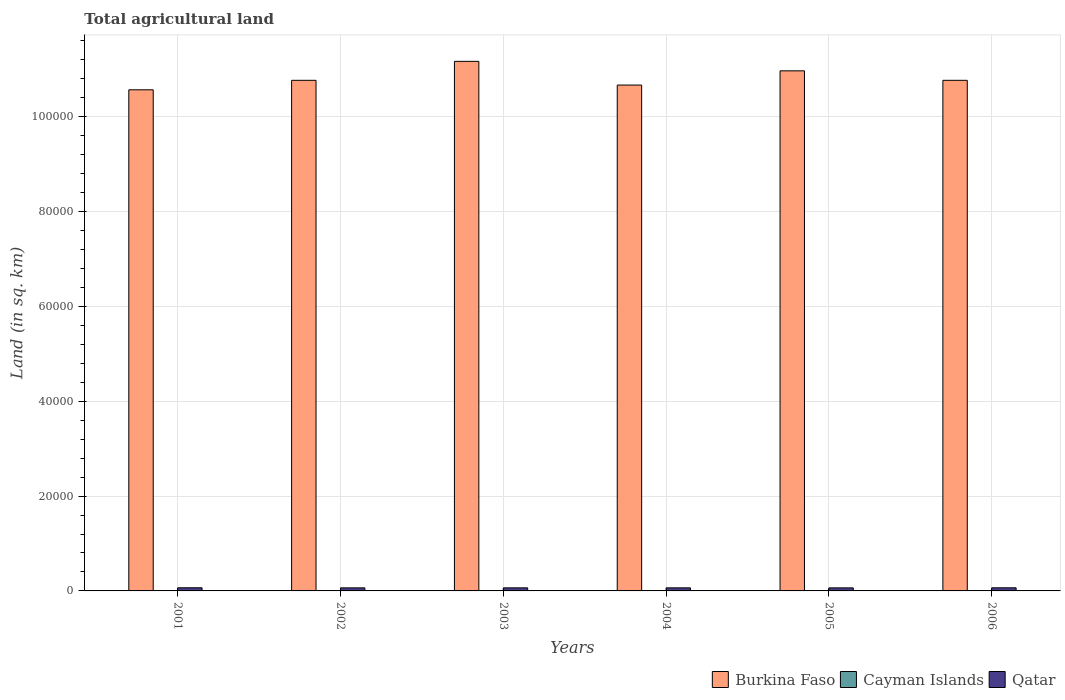How many different coloured bars are there?
Offer a terse response. 3. How many groups of bars are there?
Your answer should be compact. 6. Are the number of bars per tick equal to the number of legend labels?
Your answer should be very brief. Yes. Are the number of bars on each tick of the X-axis equal?
Your answer should be very brief. Yes. How many bars are there on the 1st tick from the left?
Offer a very short reply. 3. How many bars are there on the 2nd tick from the right?
Your response must be concise. 3. What is the label of the 6th group of bars from the left?
Give a very brief answer. 2006. In how many cases, is the number of bars for a given year not equal to the number of legend labels?
Ensure brevity in your answer.  0. What is the total agricultural land in Cayman Islands in 2003?
Keep it short and to the point. 27. Across all years, what is the maximum total agricultural land in Cayman Islands?
Keep it short and to the point. 27. Across all years, what is the minimum total agricultural land in Burkina Faso?
Your response must be concise. 1.06e+05. In which year was the total agricultural land in Burkina Faso minimum?
Ensure brevity in your answer.  2001. What is the total total agricultural land in Burkina Faso in the graph?
Ensure brevity in your answer.  6.49e+05. What is the difference between the total agricultural land in Qatar in 2005 and the total agricultural land in Cayman Islands in 2002?
Provide a short and direct response. 615. What is the average total agricultural land in Qatar per year?
Ensure brevity in your answer.  649.67. In the year 2001, what is the difference between the total agricultural land in Cayman Islands and total agricultural land in Qatar?
Offer a terse response. -636. In how many years, is the total agricultural land in Qatar greater than 20000 sq.km?
Your answer should be compact. 0. Is the total agricultural land in Burkina Faso in 2003 less than that in 2004?
Provide a succinct answer. No. What is the difference between the highest and the second highest total agricultural land in Burkina Faso?
Offer a very short reply. 2000. What is the difference between the highest and the lowest total agricultural land in Cayman Islands?
Offer a terse response. 0. In how many years, is the total agricultural land in Qatar greater than the average total agricultural land in Qatar taken over all years?
Make the answer very short. 2. What does the 2nd bar from the left in 2001 represents?
Keep it short and to the point. Cayman Islands. What does the 1st bar from the right in 2003 represents?
Your response must be concise. Qatar. How many years are there in the graph?
Keep it short and to the point. 6. What is the difference between two consecutive major ticks on the Y-axis?
Your response must be concise. 2.00e+04. What is the title of the graph?
Ensure brevity in your answer.  Total agricultural land. Does "Sub-Saharan Africa (all income levels)" appear as one of the legend labels in the graph?
Offer a very short reply. No. What is the label or title of the Y-axis?
Your answer should be very brief. Land (in sq. km). What is the Land (in sq. km) in Burkina Faso in 2001?
Keep it short and to the point. 1.06e+05. What is the Land (in sq. km) of Cayman Islands in 2001?
Ensure brevity in your answer.  27. What is the Land (in sq. km) of Qatar in 2001?
Your answer should be compact. 663. What is the Land (in sq. km) of Burkina Faso in 2002?
Offer a terse response. 1.08e+05. What is the Land (in sq. km) in Cayman Islands in 2002?
Ensure brevity in your answer.  27. What is the Land (in sq. km) in Qatar in 2002?
Offer a very short reply. 645. What is the Land (in sq. km) in Burkina Faso in 2003?
Give a very brief answer. 1.12e+05. What is the Land (in sq. km) in Qatar in 2003?
Offer a terse response. 646. What is the Land (in sq. km) in Burkina Faso in 2004?
Keep it short and to the point. 1.07e+05. What is the Land (in sq. km) of Qatar in 2004?
Offer a terse response. 646. What is the Land (in sq. km) of Burkina Faso in 2005?
Your answer should be compact. 1.10e+05. What is the Land (in sq. km) in Cayman Islands in 2005?
Your answer should be very brief. 27. What is the Land (in sq. km) in Qatar in 2005?
Your answer should be compact. 642. What is the Land (in sq. km) in Burkina Faso in 2006?
Make the answer very short. 1.08e+05. What is the Land (in sq. km) in Cayman Islands in 2006?
Offer a terse response. 27. What is the Land (in sq. km) of Qatar in 2006?
Offer a terse response. 656. Across all years, what is the maximum Land (in sq. km) of Burkina Faso?
Your response must be concise. 1.12e+05. Across all years, what is the maximum Land (in sq. km) in Qatar?
Your answer should be compact. 663. Across all years, what is the minimum Land (in sq. km) in Burkina Faso?
Provide a succinct answer. 1.06e+05. Across all years, what is the minimum Land (in sq. km) in Cayman Islands?
Offer a terse response. 27. Across all years, what is the minimum Land (in sq. km) in Qatar?
Your answer should be very brief. 642. What is the total Land (in sq. km) of Burkina Faso in the graph?
Ensure brevity in your answer.  6.49e+05. What is the total Land (in sq. km) in Cayman Islands in the graph?
Provide a succinct answer. 162. What is the total Land (in sq. km) of Qatar in the graph?
Provide a succinct answer. 3898. What is the difference between the Land (in sq. km) in Burkina Faso in 2001 and that in 2002?
Your answer should be compact. -2000. What is the difference between the Land (in sq. km) in Qatar in 2001 and that in 2002?
Give a very brief answer. 18. What is the difference between the Land (in sq. km) in Burkina Faso in 2001 and that in 2003?
Make the answer very short. -6000. What is the difference between the Land (in sq. km) in Burkina Faso in 2001 and that in 2004?
Your answer should be compact. -1000. What is the difference between the Land (in sq. km) of Cayman Islands in 2001 and that in 2004?
Your answer should be very brief. 0. What is the difference between the Land (in sq. km) of Qatar in 2001 and that in 2004?
Ensure brevity in your answer.  17. What is the difference between the Land (in sq. km) of Burkina Faso in 2001 and that in 2005?
Your response must be concise. -4000. What is the difference between the Land (in sq. km) of Qatar in 2001 and that in 2005?
Keep it short and to the point. 21. What is the difference between the Land (in sq. km) of Burkina Faso in 2001 and that in 2006?
Keep it short and to the point. -2000. What is the difference between the Land (in sq. km) in Cayman Islands in 2001 and that in 2006?
Keep it short and to the point. 0. What is the difference between the Land (in sq. km) of Burkina Faso in 2002 and that in 2003?
Ensure brevity in your answer.  -4000. What is the difference between the Land (in sq. km) of Qatar in 2002 and that in 2004?
Offer a terse response. -1. What is the difference between the Land (in sq. km) in Burkina Faso in 2002 and that in 2005?
Give a very brief answer. -2000. What is the difference between the Land (in sq. km) of Cayman Islands in 2002 and that in 2005?
Provide a short and direct response. 0. What is the difference between the Land (in sq. km) in Qatar in 2002 and that in 2005?
Give a very brief answer. 3. What is the difference between the Land (in sq. km) of Cayman Islands in 2002 and that in 2006?
Keep it short and to the point. 0. What is the difference between the Land (in sq. km) of Cayman Islands in 2003 and that in 2004?
Keep it short and to the point. 0. What is the difference between the Land (in sq. km) of Qatar in 2003 and that in 2005?
Offer a very short reply. 4. What is the difference between the Land (in sq. km) in Burkina Faso in 2003 and that in 2006?
Offer a very short reply. 4000. What is the difference between the Land (in sq. km) in Cayman Islands in 2003 and that in 2006?
Offer a terse response. 0. What is the difference between the Land (in sq. km) of Burkina Faso in 2004 and that in 2005?
Provide a succinct answer. -3000. What is the difference between the Land (in sq. km) of Qatar in 2004 and that in 2005?
Your answer should be very brief. 4. What is the difference between the Land (in sq. km) of Burkina Faso in 2004 and that in 2006?
Your answer should be compact. -1000. What is the difference between the Land (in sq. km) in Qatar in 2004 and that in 2006?
Your response must be concise. -10. What is the difference between the Land (in sq. km) of Burkina Faso in 2005 and that in 2006?
Offer a terse response. 2000. What is the difference between the Land (in sq. km) of Burkina Faso in 2001 and the Land (in sq. km) of Cayman Islands in 2002?
Provide a short and direct response. 1.06e+05. What is the difference between the Land (in sq. km) of Burkina Faso in 2001 and the Land (in sq. km) of Qatar in 2002?
Ensure brevity in your answer.  1.05e+05. What is the difference between the Land (in sq. km) in Cayman Islands in 2001 and the Land (in sq. km) in Qatar in 2002?
Keep it short and to the point. -618. What is the difference between the Land (in sq. km) of Burkina Faso in 2001 and the Land (in sq. km) of Cayman Islands in 2003?
Make the answer very short. 1.06e+05. What is the difference between the Land (in sq. km) in Burkina Faso in 2001 and the Land (in sq. km) in Qatar in 2003?
Provide a succinct answer. 1.05e+05. What is the difference between the Land (in sq. km) in Cayman Islands in 2001 and the Land (in sq. km) in Qatar in 2003?
Provide a short and direct response. -619. What is the difference between the Land (in sq. km) of Burkina Faso in 2001 and the Land (in sq. km) of Cayman Islands in 2004?
Offer a very short reply. 1.06e+05. What is the difference between the Land (in sq. km) in Burkina Faso in 2001 and the Land (in sq. km) in Qatar in 2004?
Offer a terse response. 1.05e+05. What is the difference between the Land (in sq. km) in Cayman Islands in 2001 and the Land (in sq. km) in Qatar in 2004?
Provide a succinct answer. -619. What is the difference between the Land (in sq. km) in Burkina Faso in 2001 and the Land (in sq. km) in Cayman Islands in 2005?
Offer a terse response. 1.06e+05. What is the difference between the Land (in sq. km) in Burkina Faso in 2001 and the Land (in sq. km) in Qatar in 2005?
Offer a very short reply. 1.05e+05. What is the difference between the Land (in sq. km) in Cayman Islands in 2001 and the Land (in sq. km) in Qatar in 2005?
Your answer should be compact. -615. What is the difference between the Land (in sq. km) in Burkina Faso in 2001 and the Land (in sq. km) in Cayman Islands in 2006?
Ensure brevity in your answer.  1.06e+05. What is the difference between the Land (in sq. km) of Burkina Faso in 2001 and the Land (in sq. km) of Qatar in 2006?
Give a very brief answer. 1.05e+05. What is the difference between the Land (in sq. km) of Cayman Islands in 2001 and the Land (in sq. km) of Qatar in 2006?
Provide a succinct answer. -629. What is the difference between the Land (in sq. km) in Burkina Faso in 2002 and the Land (in sq. km) in Cayman Islands in 2003?
Offer a very short reply. 1.08e+05. What is the difference between the Land (in sq. km) in Burkina Faso in 2002 and the Land (in sq. km) in Qatar in 2003?
Offer a very short reply. 1.07e+05. What is the difference between the Land (in sq. km) in Cayman Islands in 2002 and the Land (in sq. km) in Qatar in 2003?
Make the answer very short. -619. What is the difference between the Land (in sq. km) in Burkina Faso in 2002 and the Land (in sq. km) in Cayman Islands in 2004?
Provide a short and direct response. 1.08e+05. What is the difference between the Land (in sq. km) of Burkina Faso in 2002 and the Land (in sq. km) of Qatar in 2004?
Provide a succinct answer. 1.07e+05. What is the difference between the Land (in sq. km) of Cayman Islands in 2002 and the Land (in sq. km) of Qatar in 2004?
Your response must be concise. -619. What is the difference between the Land (in sq. km) in Burkina Faso in 2002 and the Land (in sq. km) in Cayman Islands in 2005?
Make the answer very short. 1.08e+05. What is the difference between the Land (in sq. km) of Burkina Faso in 2002 and the Land (in sq. km) of Qatar in 2005?
Give a very brief answer. 1.07e+05. What is the difference between the Land (in sq. km) in Cayman Islands in 2002 and the Land (in sq. km) in Qatar in 2005?
Your answer should be compact. -615. What is the difference between the Land (in sq. km) of Burkina Faso in 2002 and the Land (in sq. km) of Cayman Islands in 2006?
Your answer should be very brief. 1.08e+05. What is the difference between the Land (in sq. km) of Burkina Faso in 2002 and the Land (in sq. km) of Qatar in 2006?
Your answer should be compact. 1.07e+05. What is the difference between the Land (in sq. km) of Cayman Islands in 2002 and the Land (in sq. km) of Qatar in 2006?
Provide a short and direct response. -629. What is the difference between the Land (in sq. km) in Burkina Faso in 2003 and the Land (in sq. km) in Cayman Islands in 2004?
Offer a terse response. 1.12e+05. What is the difference between the Land (in sq. km) in Burkina Faso in 2003 and the Land (in sq. km) in Qatar in 2004?
Offer a very short reply. 1.11e+05. What is the difference between the Land (in sq. km) in Cayman Islands in 2003 and the Land (in sq. km) in Qatar in 2004?
Offer a very short reply. -619. What is the difference between the Land (in sq. km) of Burkina Faso in 2003 and the Land (in sq. km) of Cayman Islands in 2005?
Give a very brief answer. 1.12e+05. What is the difference between the Land (in sq. km) in Burkina Faso in 2003 and the Land (in sq. km) in Qatar in 2005?
Your answer should be very brief. 1.11e+05. What is the difference between the Land (in sq. km) in Cayman Islands in 2003 and the Land (in sq. km) in Qatar in 2005?
Provide a succinct answer. -615. What is the difference between the Land (in sq. km) of Burkina Faso in 2003 and the Land (in sq. km) of Cayman Islands in 2006?
Give a very brief answer. 1.12e+05. What is the difference between the Land (in sq. km) in Burkina Faso in 2003 and the Land (in sq. km) in Qatar in 2006?
Ensure brevity in your answer.  1.11e+05. What is the difference between the Land (in sq. km) in Cayman Islands in 2003 and the Land (in sq. km) in Qatar in 2006?
Offer a terse response. -629. What is the difference between the Land (in sq. km) of Burkina Faso in 2004 and the Land (in sq. km) of Cayman Islands in 2005?
Your response must be concise. 1.07e+05. What is the difference between the Land (in sq. km) of Burkina Faso in 2004 and the Land (in sq. km) of Qatar in 2005?
Your answer should be very brief. 1.06e+05. What is the difference between the Land (in sq. km) of Cayman Islands in 2004 and the Land (in sq. km) of Qatar in 2005?
Offer a very short reply. -615. What is the difference between the Land (in sq. km) of Burkina Faso in 2004 and the Land (in sq. km) of Cayman Islands in 2006?
Give a very brief answer. 1.07e+05. What is the difference between the Land (in sq. km) of Burkina Faso in 2004 and the Land (in sq. km) of Qatar in 2006?
Give a very brief answer. 1.06e+05. What is the difference between the Land (in sq. km) in Cayman Islands in 2004 and the Land (in sq. km) in Qatar in 2006?
Provide a succinct answer. -629. What is the difference between the Land (in sq. km) of Burkina Faso in 2005 and the Land (in sq. km) of Cayman Islands in 2006?
Your answer should be compact. 1.10e+05. What is the difference between the Land (in sq. km) of Burkina Faso in 2005 and the Land (in sq. km) of Qatar in 2006?
Keep it short and to the point. 1.09e+05. What is the difference between the Land (in sq. km) in Cayman Islands in 2005 and the Land (in sq. km) in Qatar in 2006?
Provide a short and direct response. -629. What is the average Land (in sq. km) of Burkina Faso per year?
Your answer should be compact. 1.08e+05. What is the average Land (in sq. km) in Qatar per year?
Ensure brevity in your answer.  649.67. In the year 2001, what is the difference between the Land (in sq. km) in Burkina Faso and Land (in sq. km) in Cayman Islands?
Your answer should be very brief. 1.06e+05. In the year 2001, what is the difference between the Land (in sq. km) of Burkina Faso and Land (in sq. km) of Qatar?
Your response must be concise. 1.05e+05. In the year 2001, what is the difference between the Land (in sq. km) in Cayman Islands and Land (in sq. km) in Qatar?
Offer a terse response. -636. In the year 2002, what is the difference between the Land (in sq. km) of Burkina Faso and Land (in sq. km) of Cayman Islands?
Ensure brevity in your answer.  1.08e+05. In the year 2002, what is the difference between the Land (in sq. km) of Burkina Faso and Land (in sq. km) of Qatar?
Make the answer very short. 1.07e+05. In the year 2002, what is the difference between the Land (in sq. km) of Cayman Islands and Land (in sq. km) of Qatar?
Keep it short and to the point. -618. In the year 2003, what is the difference between the Land (in sq. km) of Burkina Faso and Land (in sq. km) of Cayman Islands?
Provide a short and direct response. 1.12e+05. In the year 2003, what is the difference between the Land (in sq. km) in Burkina Faso and Land (in sq. km) in Qatar?
Your answer should be compact. 1.11e+05. In the year 2003, what is the difference between the Land (in sq. km) of Cayman Islands and Land (in sq. km) of Qatar?
Your answer should be very brief. -619. In the year 2004, what is the difference between the Land (in sq. km) in Burkina Faso and Land (in sq. km) in Cayman Islands?
Make the answer very short. 1.07e+05. In the year 2004, what is the difference between the Land (in sq. km) in Burkina Faso and Land (in sq. km) in Qatar?
Give a very brief answer. 1.06e+05. In the year 2004, what is the difference between the Land (in sq. km) in Cayman Islands and Land (in sq. km) in Qatar?
Offer a very short reply. -619. In the year 2005, what is the difference between the Land (in sq. km) in Burkina Faso and Land (in sq. km) in Cayman Islands?
Provide a short and direct response. 1.10e+05. In the year 2005, what is the difference between the Land (in sq. km) in Burkina Faso and Land (in sq. km) in Qatar?
Provide a succinct answer. 1.09e+05. In the year 2005, what is the difference between the Land (in sq. km) in Cayman Islands and Land (in sq. km) in Qatar?
Keep it short and to the point. -615. In the year 2006, what is the difference between the Land (in sq. km) of Burkina Faso and Land (in sq. km) of Cayman Islands?
Your answer should be compact. 1.08e+05. In the year 2006, what is the difference between the Land (in sq. km) in Burkina Faso and Land (in sq. km) in Qatar?
Keep it short and to the point. 1.07e+05. In the year 2006, what is the difference between the Land (in sq. km) of Cayman Islands and Land (in sq. km) of Qatar?
Offer a very short reply. -629. What is the ratio of the Land (in sq. km) of Burkina Faso in 2001 to that in 2002?
Keep it short and to the point. 0.98. What is the ratio of the Land (in sq. km) of Cayman Islands in 2001 to that in 2002?
Provide a short and direct response. 1. What is the ratio of the Land (in sq. km) of Qatar in 2001 to that in 2002?
Your response must be concise. 1.03. What is the ratio of the Land (in sq. km) in Burkina Faso in 2001 to that in 2003?
Provide a succinct answer. 0.95. What is the ratio of the Land (in sq. km) of Cayman Islands in 2001 to that in 2003?
Provide a short and direct response. 1. What is the ratio of the Land (in sq. km) in Qatar in 2001 to that in 2003?
Offer a terse response. 1.03. What is the ratio of the Land (in sq. km) of Burkina Faso in 2001 to that in 2004?
Make the answer very short. 0.99. What is the ratio of the Land (in sq. km) in Cayman Islands in 2001 to that in 2004?
Keep it short and to the point. 1. What is the ratio of the Land (in sq. km) in Qatar in 2001 to that in 2004?
Provide a succinct answer. 1.03. What is the ratio of the Land (in sq. km) of Burkina Faso in 2001 to that in 2005?
Your response must be concise. 0.96. What is the ratio of the Land (in sq. km) in Qatar in 2001 to that in 2005?
Your response must be concise. 1.03. What is the ratio of the Land (in sq. km) of Burkina Faso in 2001 to that in 2006?
Give a very brief answer. 0.98. What is the ratio of the Land (in sq. km) in Cayman Islands in 2001 to that in 2006?
Make the answer very short. 1. What is the ratio of the Land (in sq. km) of Qatar in 2001 to that in 2006?
Offer a very short reply. 1.01. What is the ratio of the Land (in sq. km) of Burkina Faso in 2002 to that in 2003?
Your answer should be very brief. 0.96. What is the ratio of the Land (in sq. km) in Cayman Islands in 2002 to that in 2003?
Provide a short and direct response. 1. What is the ratio of the Land (in sq. km) in Qatar in 2002 to that in 2003?
Provide a succinct answer. 1. What is the ratio of the Land (in sq. km) of Burkina Faso in 2002 to that in 2004?
Make the answer very short. 1.01. What is the ratio of the Land (in sq. km) in Burkina Faso in 2002 to that in 2005?
Make the answer very short. 0.98. What is the ratio of the Land (in sq. km) of Cayman Islands in 2002 to that in 2005?
Your response must be concise. 1. What is the ratio of the Land (in sq. km) of Qatar in 2002 to that in 2005?
Offer a terse response. 1. What is the ratio of the Land (in sq. km) in Burkina Faso in 2002 to that in 2006?
Make the answer very short. 1. What is the ratio of the Land (in sq. km) in Qatar in 2002 to that in 2006?
Give a very brief answer. 0.98. What is the ratio of the Land (in sq. km) in Burkina Faso in 2003 to that in 2004?
Provide a succinct answer. 1.05. What is the ratio of the Land (in sq. km) of Cayman Islands in 2003 to that in 2004?
Give a very brief answer. 1. What is the ratio of the Land (in sq. km) in Qatar in 2003 to that in 2004?
Make the answer very short. 1. What is the ratio of the Land (in sq. km) in Burkina Faso in 2003 to that in 2005?
Ensure brevity in your answer.  1.02. What is the ratio of the Land (in sq. km) of Cayman Islands in 2003 to that in 2005?
Offer a terse response. 1. What is the ratio of the Land (in sq. km) of Burkina Faso in 2003 to that in 2006?
Make the answer very short. 1.04. What is the ratio of the Land (in sq. km) in Cayman Islands in 2003 to that in 2006?
Keep it short and to the point. 1. What is the ratio of the Land (in sq. km) of Qatar in 2003 to that in 2006?
Offer a very short reply. 0.98. What is the ratio of the Land (in sq. km) of Burkina Faso in 2004 to that in 2005?
Ensure brevity in your answer.  0.97. What is the ratio of the Land (in sq. km) in Cayman Islands in 2004 to that in 2006?
Offer a very short reply. 1. What is the ratio of the Land (in sq. km) of Qatar in 2004 to that in 2006?
Give a very brief answer. 0.98. What is the ratio of the Land (in sq. km) in Burkina Faso in 2005 to that in 2006?
Keep it short and to the point. 1.02. What is the ratio of the Land (in sq. km) in Qatar in 2005 to that in 2006?
Make the answer very short. 0.98. What is the difference between the highest and the second highest Land (in sq. km) in Burkina Faso?
Your answer should be very brief. 2000. What is the difference between the highest and the second highest Land (in sq. km) of Cayman Islands?
Your answer should be very brief. 0. What is the difference between the highest and the second highest Land (in sq. km) of Qatar?
Offer a terse response. 7. What is the difference between the highest and the lowest Land (in sq. km) of Burkina Faso?
Offer a terse response. 6000. 